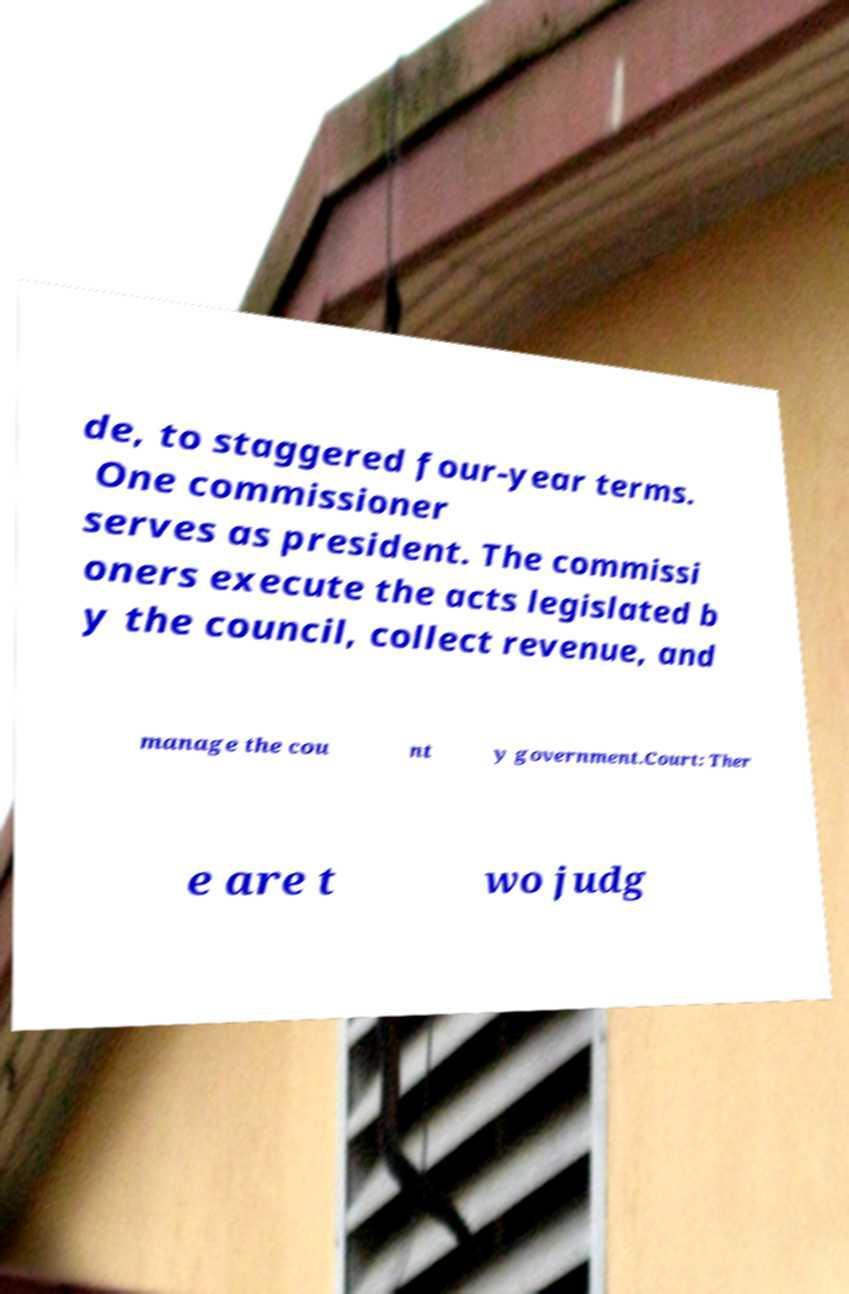What messages or text are displayed in this image? I need them in a readable, typed format. de, to staggered four-year terms. One commissioner serves as president. The commissi oners execute the acts legislated b y the council, collect revenue, and manage the cou nt y government.Court: Ther e are t wo judg 